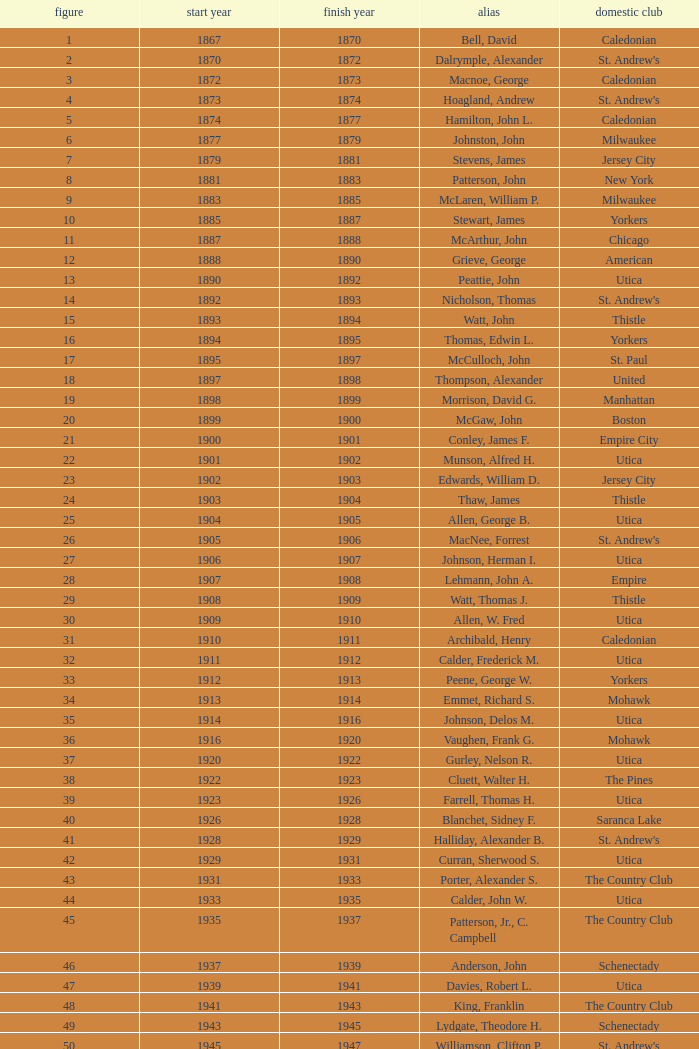Which Year Start has a Number of 28? 1907.0. 